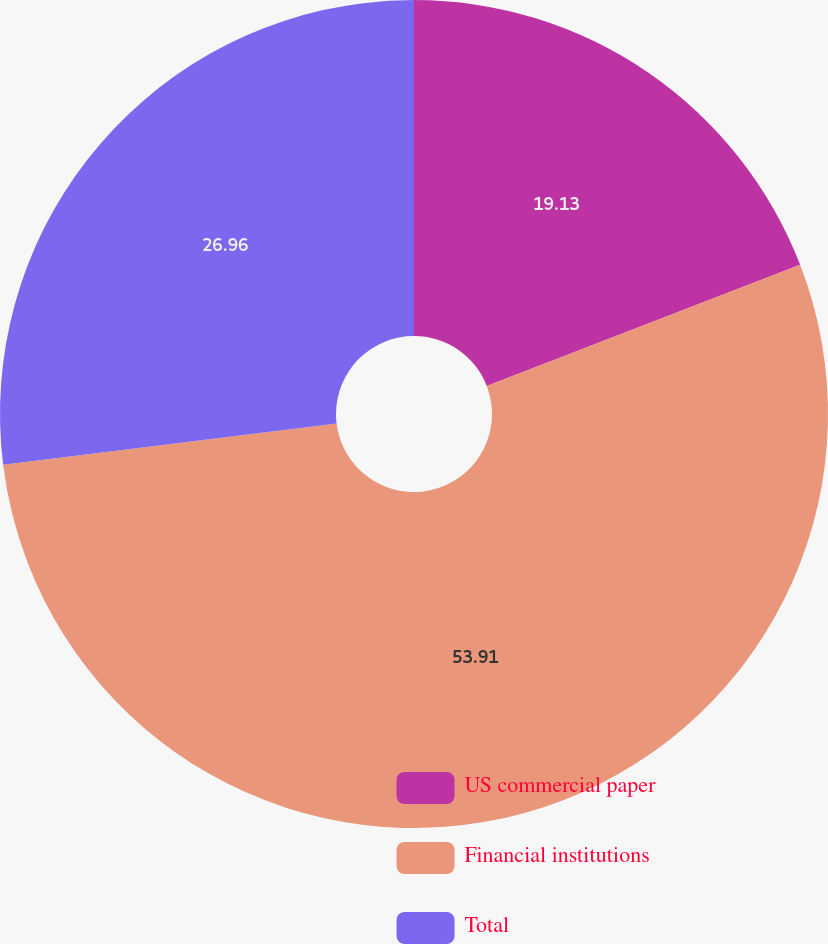Convert chart to OTSL. <chart><loc_0><loc_0><loc_500><loc_500><pie_chart><fcel>US commercial paper<fcel>Financial institutions<fcel>Total<nl><fcel>19.13%<fcel>53.91%<fcel>26.96%<nl></chart> 